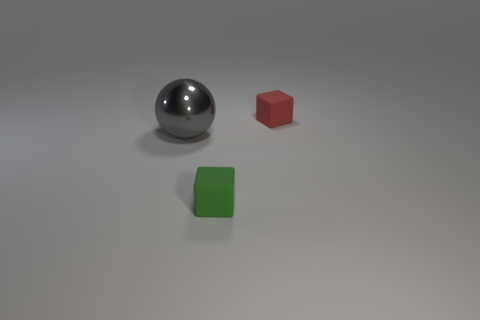Add 1 big gray objects. How many objects exist? 4 Subtract all spheres. How many objects are left? 2 Add 1 small purple objects. How many small purple objects exist? 1 Subtract 0 blue cylinders. How many objects are left? 3 Subtract all cubes. Subtract all small blue rubber objects. How many objects are left? 1 Add 3 small green cubes. How many small green cubes are left? 4 